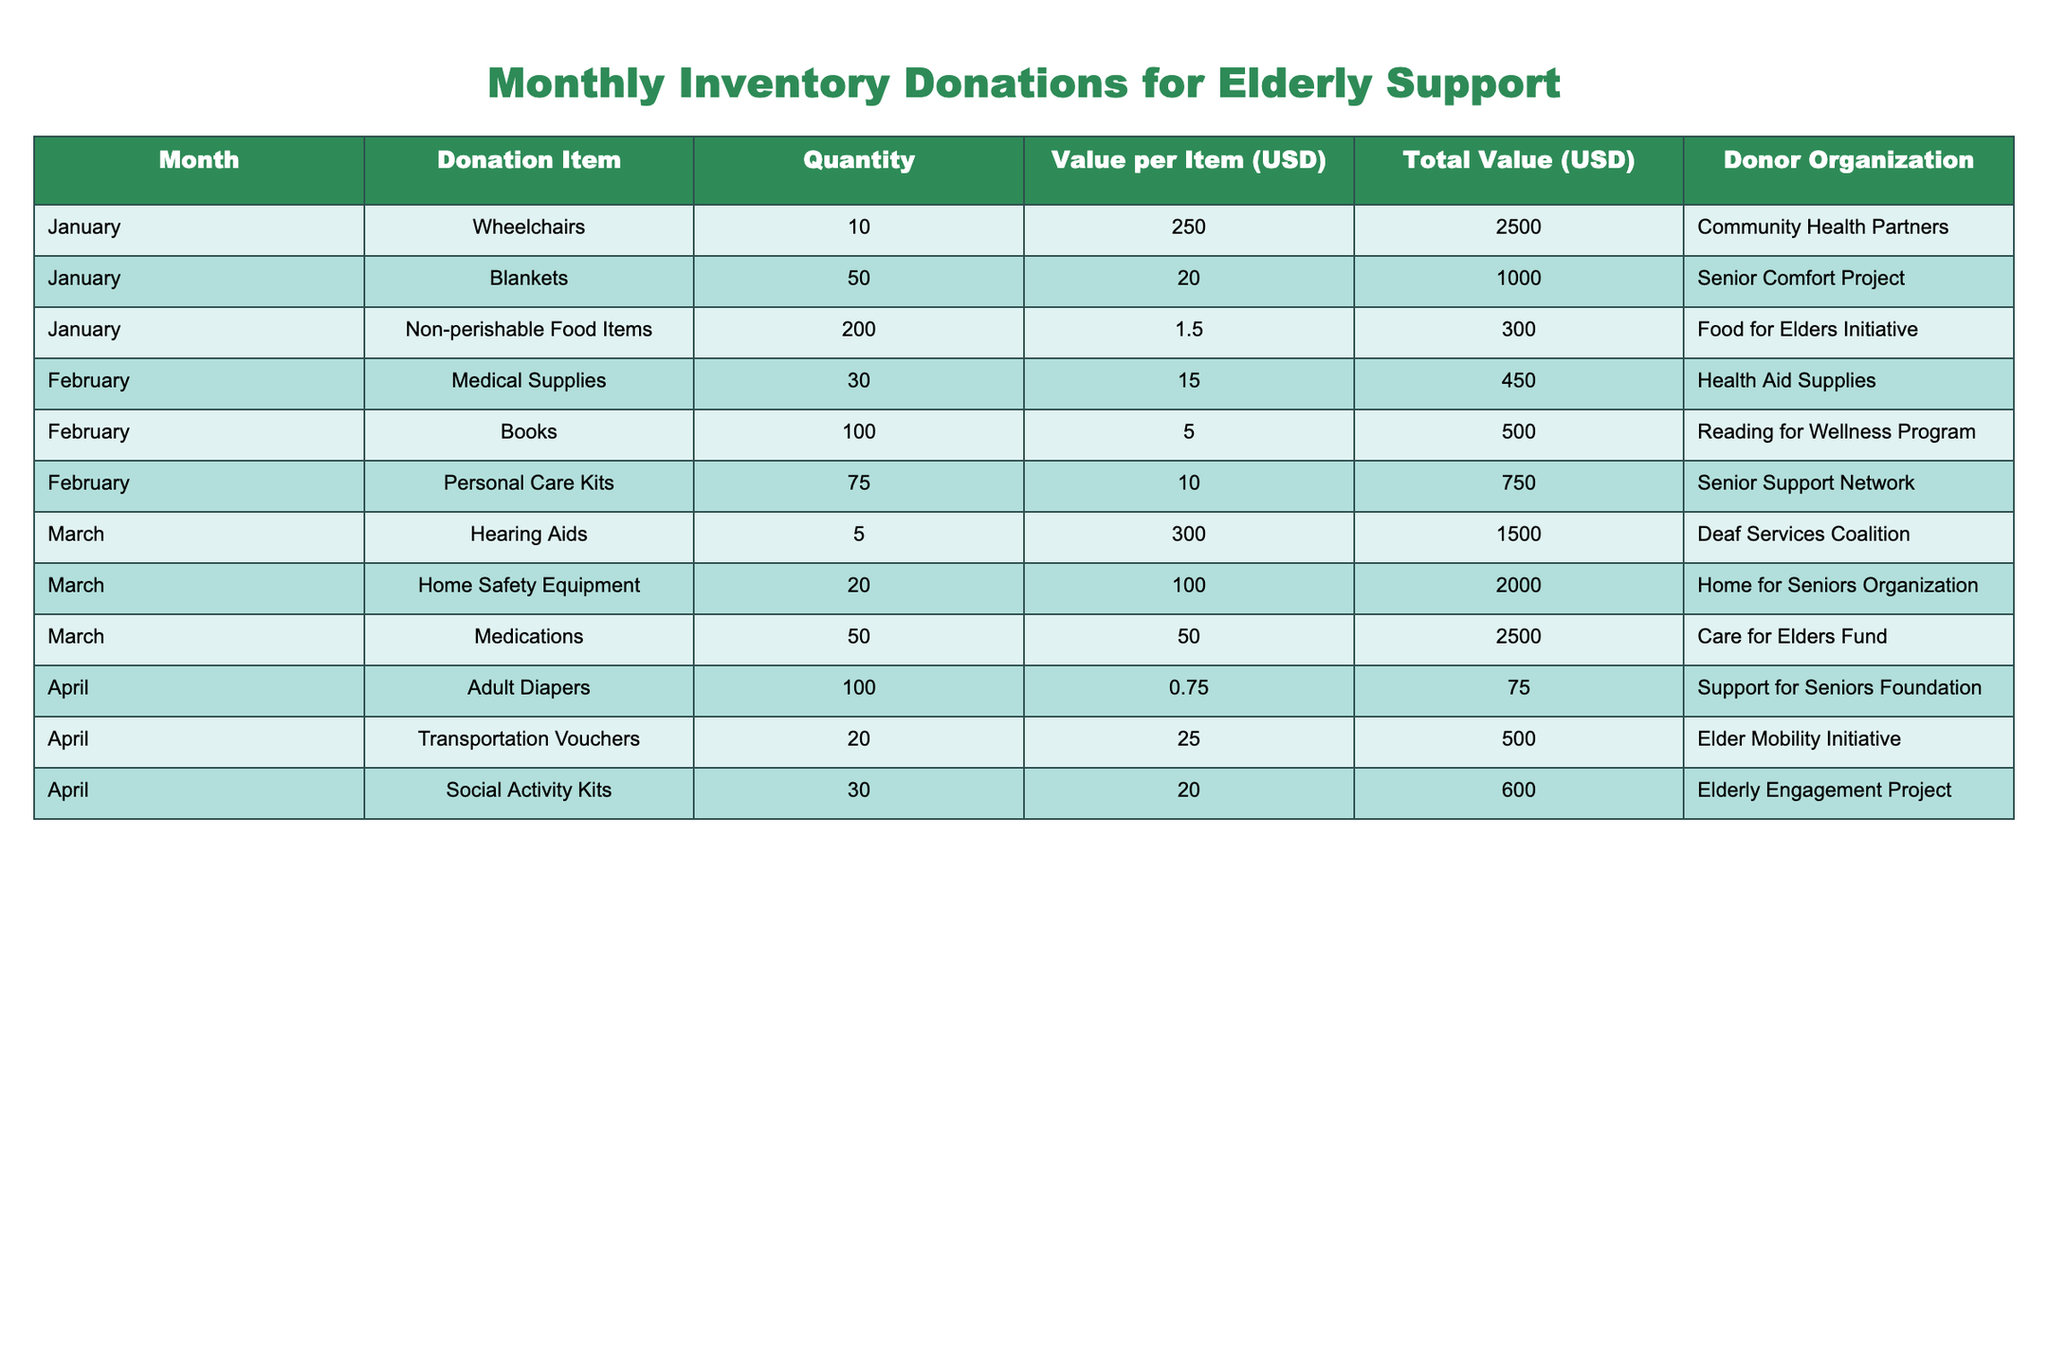What was the total quantity of wheelchairs donated? The table shows that in January, the donation of wheelchairs was listed as 10. Therefore, the total quantity of wheelchairs donated is 10.
Answer: 10 Which month had the highest total value of donations? To find this, we need to compare the total value of donations for each month based on the table: January (2500 + 1000 + 300 = 3800), February (450 + 500 + 750 = 1700), March (1500 + 2000 + 2500 = 6000), and April (75 + 500 + 600 = 1175). March has the highest total value of 6000.
Answer: March How many total individual items were donated across all months? We need to sum up the quantity of all items: January (10 + 50 + 200 = 260), February (30 + 100 + 75 = 205), March (5 + 20 + 50 = 75), and April (100 + 20 + 30 = 150). Thus, the total is 260 + 205 + 75 + 150 = 690.
Answer: 690 Did the value of the personal care kits exceed $800? The table states that the value of each personal care kit is $10 and there were 75 kits donated. So, the total value is 75 * 10 = $750, which does not exceed $800.
Answer: No What is the average value of the donations for the month of April? In April, the total value of donations is $75 (Adult Diapers) + $500 (Transportation Vouchers) + $600 (Social Activity Kits) = $1175. There are 3 donations, so the average value is 1175 / 3 = approximately 391.67.
Answer: 391.67 How many donations were made by the Elder Mobility Initiative? The table indicates that there is only one entry for donations by the Elder Mobility Initiative in April with 20 Transportation Vouchers. Thus, there is 1 donation entry.
Answer: 1 What is the total value of non-perishable food items donated? The table shows that 200 non-perishable food items were donated at a value of $1.50 each. Therefore, the total value is 200 * 1.5 = 300.
Answer: 300 Which organization contributed the most valuable single donation? Analyzing the total value of donations, the Care for Elders Fund contributed 2500 for Medications, which is the highest single donation value in the table.
Answer: Care for Elders Fund 